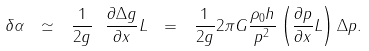<formula> <loc_0><loc_0><loc_500><loc_500>\delta \alpha \ \simeq \ \frac { 1 } { 2 g } \ \frac { \partial \Delta g } { \partial x } L \ = \ \frac { 1 } { 2 g } 2 \pi G \frac { \rho _ { 0 } h } { p ^ { 2 } } \left ( \frac { \partial p } { \partial x } L \right ) \Delta p .</formula> 